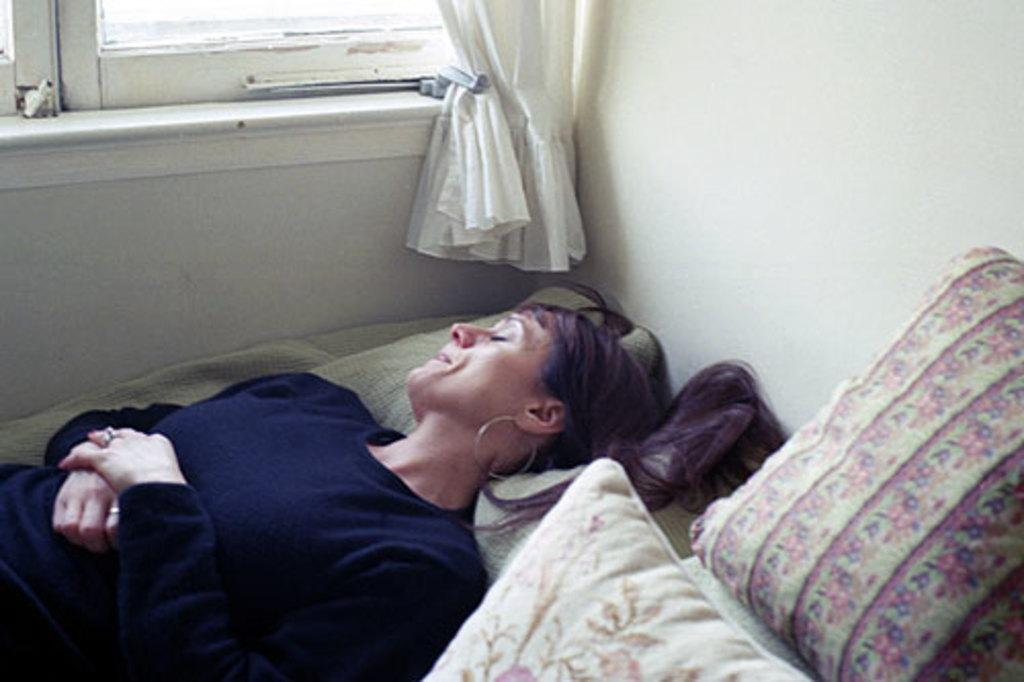What is the woman in the image doing? The woman is lying on the bed. What objects are near the woman on the bed? There are pillows beside the woman. What can be seen in the room besides the woman and pillows? There is a window in the room. What is on the other side of the window? There is a curtain hanging on the other side of the window. What does the grandmother do to the queen in the image? There is no grandmother or queen present in the image. 